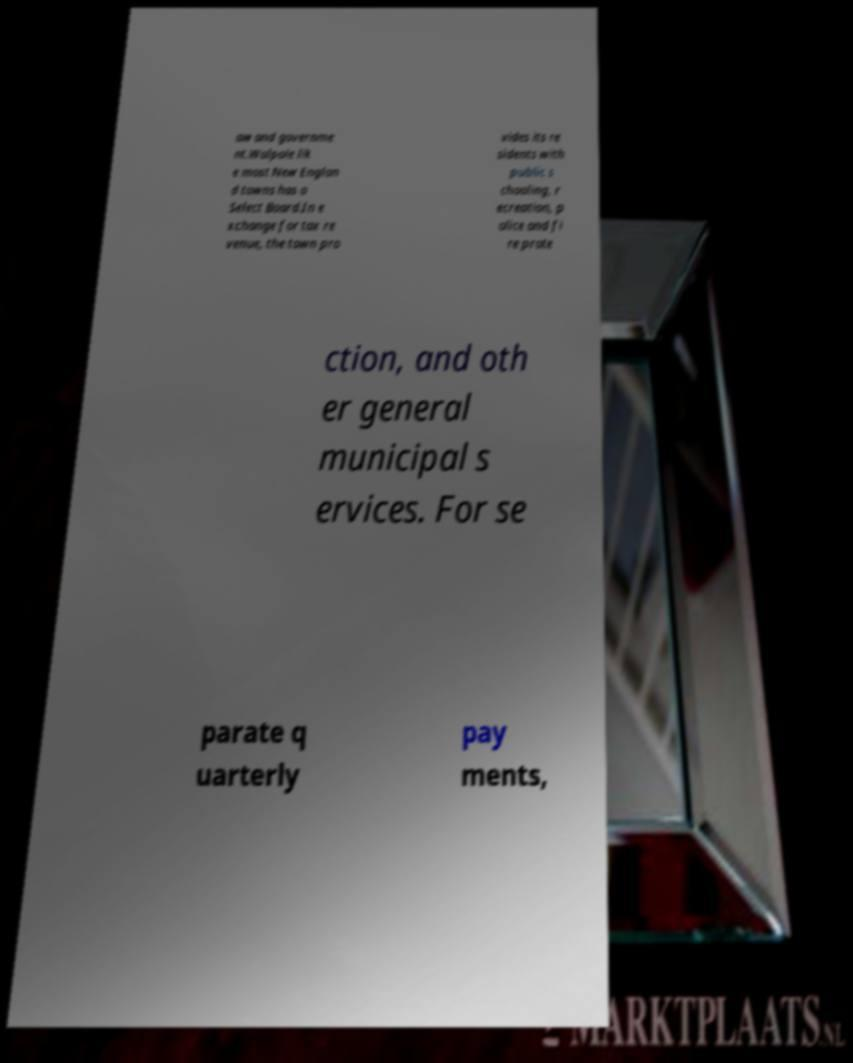I need the written content from this picture converted into text. Can you do that? aw and governme nt.Walpole lik e most New Englan d towns has a Select Board.In e xchange for tax re venue, the town pro vides its re sidents with public s chooling, r ecreation, p olice and fi re prote ction, and oth er general municipal s ervices. For se parate q uarterly pay ments, 